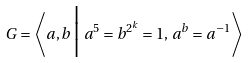Convert formula to latex. <formula><loc_0><loc_0><loc_500><loc_500>G = \left \langle a , b \, \Big | \, a ^ { 5 } = b ^ { 2 ^ { k } } = 1 , \, a ^ { b } = a ^ { - 1 } \right \rangle</formula> 